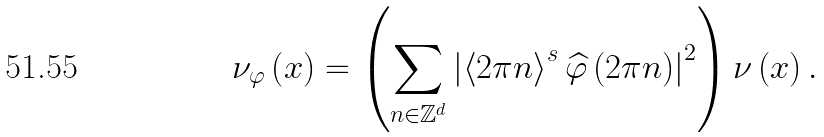<formula> <loc_0><loc_0><loc_500><loc_500>\nu _ { \varphi } \left ( x \right ) = \left ( \sum _ { n \in \mathbb { Z } ^ { d } } \left | \left \langle 2 \pi n \right \rangle ^ { s } \widehat { \varphi } \left ( 2 \pi n \right ) \right | ^ { 2 } \right ) \nu \left ( x \right ) .</formula> 